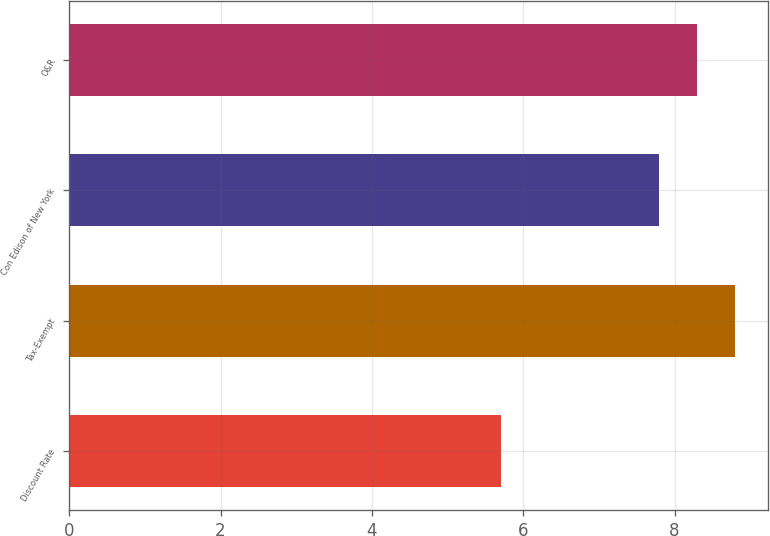<chart> <loc_0><loc_0><loc_500><loc_500><bar_chart><fcel>Discount Rate<fcel>Tax-Exempt<fcel>Con Edison of New York<fcel>O&R<nl><fcel>5.7<fcel>8.8<fcel>7.8<fcel>8.3<nl></chart> 